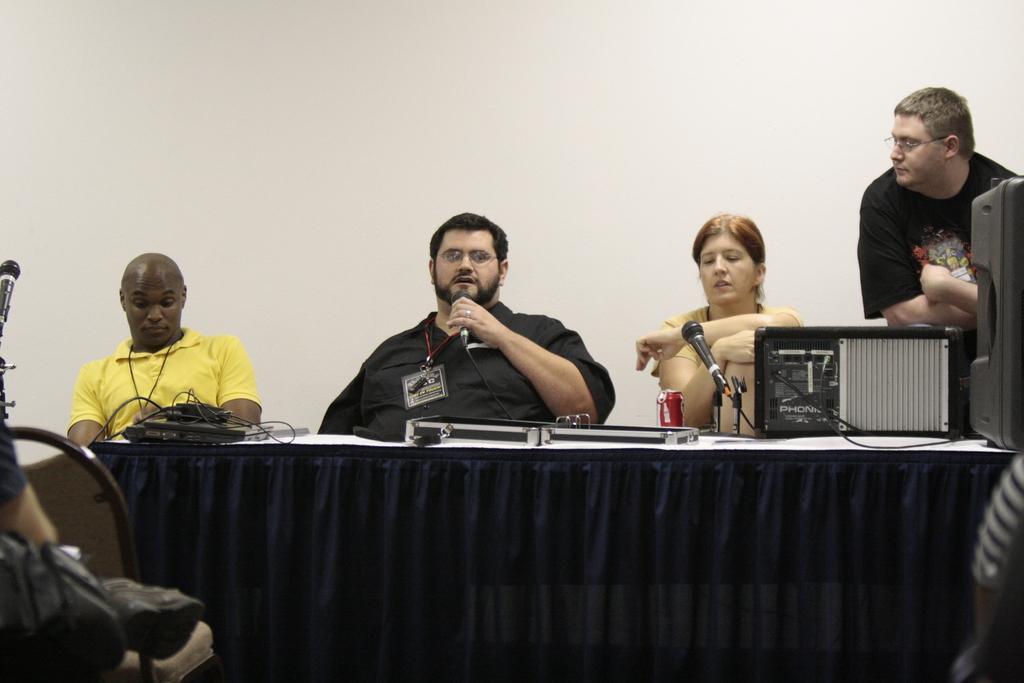Could you give a brief overview of what you see in this image? In this picture we can see some persons sitting on the chairs. And this is the table, there is a cloth on the table. This is the mike. And here we can see some electronic devices. And this is the wall. 